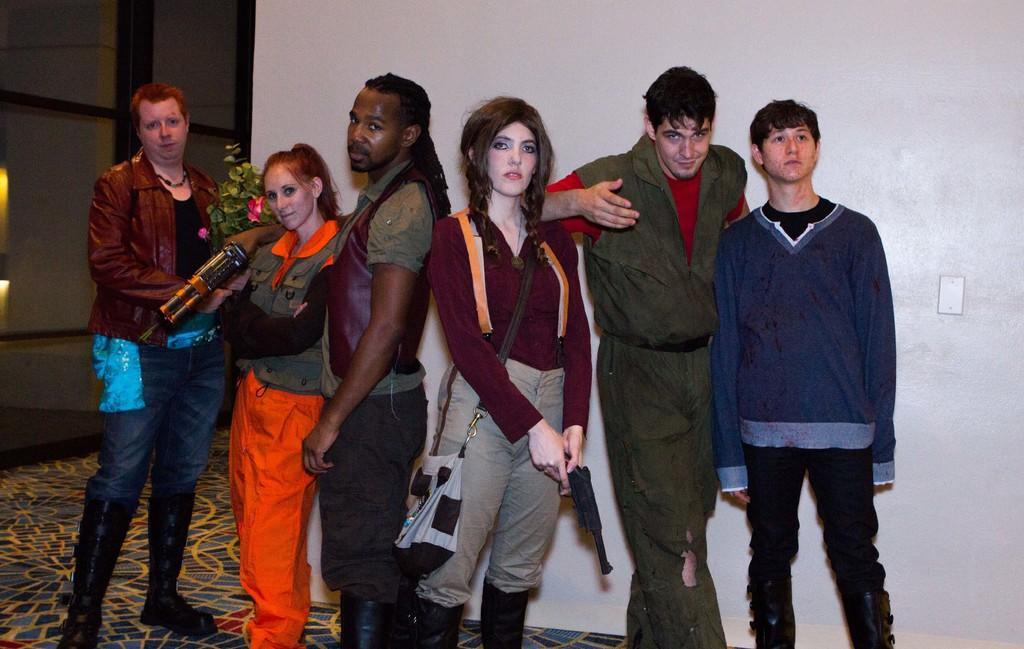Could you give a brief overview of what you see in this image? In this picture we can see a group of people standing and the two people holding some objects. Behind the people there is a house plant, a wall and a glass window. 